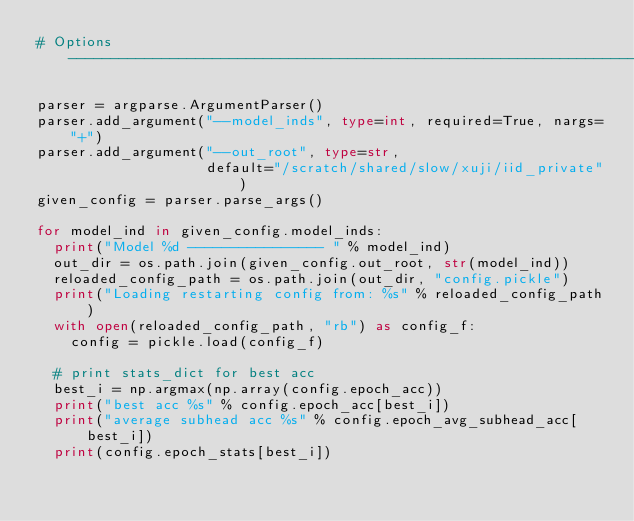Convert code to text. <code><loc_0><loc_0><loc_500><loc_500><_Python_># Options ----------------------------------------------------------------------

parser = argparse.ArgumentParser()
parser.add_argument("--model_inds", type=int, required=True, nargs="+")
parser.add_argument("--out_root", type=str,
                    default="/scratch/shared/slow/xuji/iid_private")
given_config = parser.parse_args()

for model_ind in given_config.model_inds:
  print("Model %d ---------------- " % model_ind)
  out_dir = os.path.join(given_config.out_root, str(model_ind))
  reloaded_config_path = os.path.join(out_dir, "config.pickle")
  print("Loading restarting config from: %s" % reloaded_config_path)
  with open(reloaded_config_path, "rb") as config_f:
    config = pickle.load(config_f)

  # print stats_dict for best acc
  best_i = np.argmax(np.array(config.epoch_acc))
  print("best acc %s" % config.epoch_acc[best_i])
  print("average subhead acc %s" % config.epoch_avg_subhead_acc[best_i])
  print(config.epoch_stats[best_i])
</code> 